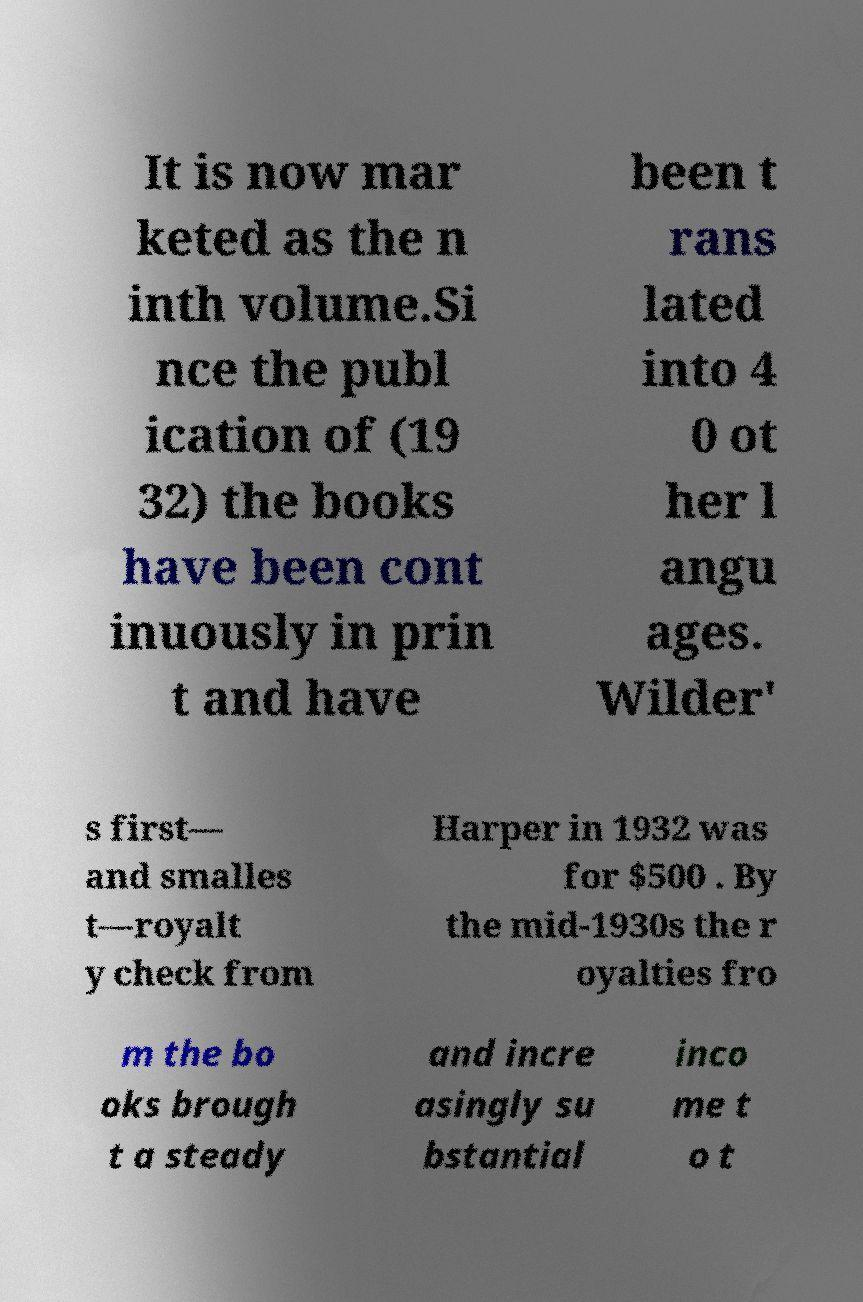Can you accurately transcribe the text from the provided image for me? It is now mar keted as the n inth volume.Si nce the publ ication of (19 32) the books have been cont inuously in prin t and have been t rans lated into 4 0 ot her l angu ages. Wilder' s first— and smalles t—royalt y check from Harper in 1932 was for $500 . By the mid-1930s the r oyalties fro m the bo oks brough t a steady and incre asingly su bstantial inco me t o t 